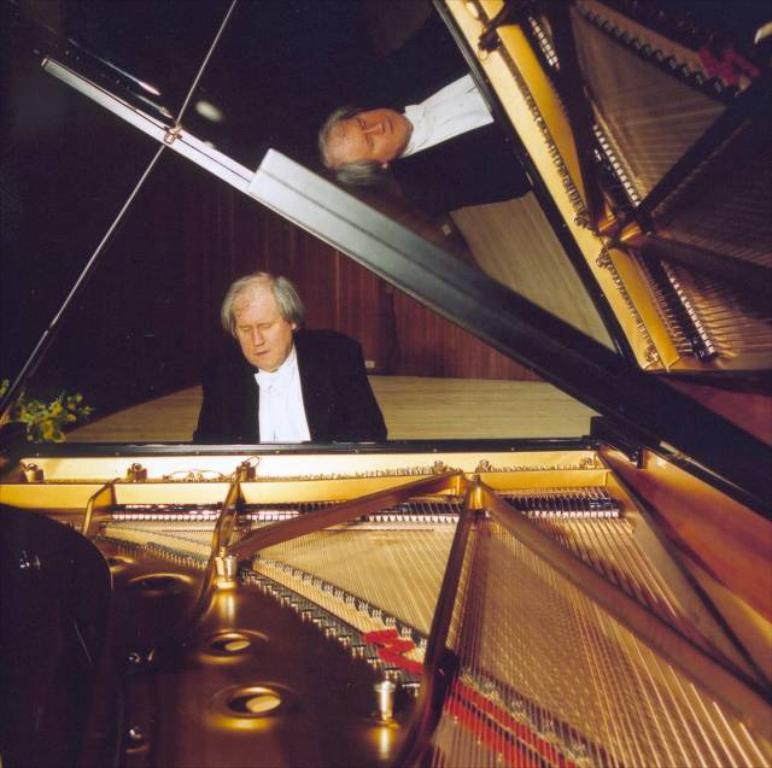What is the main subject of the image? The main subject of the image is a man. What is the man doing in the image? The man is playing a piano in the image. What type of grape can be seen falling from the sky in the image? There is no grape present in the image, and no grapes are falling from the sky. 